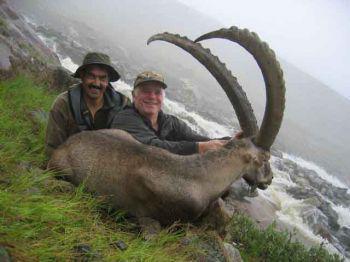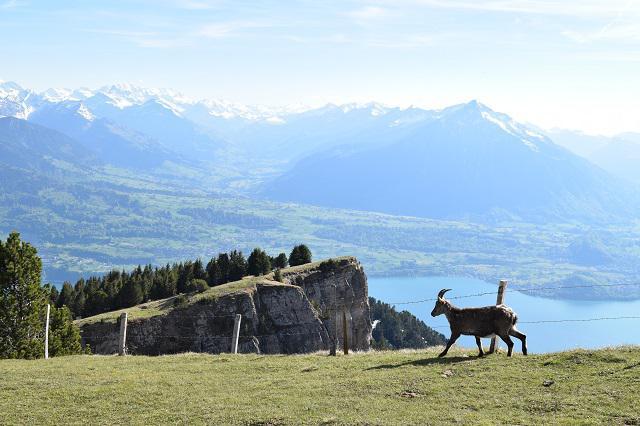The first image is the image on the left, the second image is the image on the right. For the images displayed, is the sentence "At least one man is posed behind a downed long-horned animal in one image." factually correct? Answer yes or no. Yes. The first image is the image on the left, the second image is the image on the right. For the images displayed, is the sentence "At least one person is posing with a horned animal in one of the pictures." factually correct? Answer yes or no. Yes. 